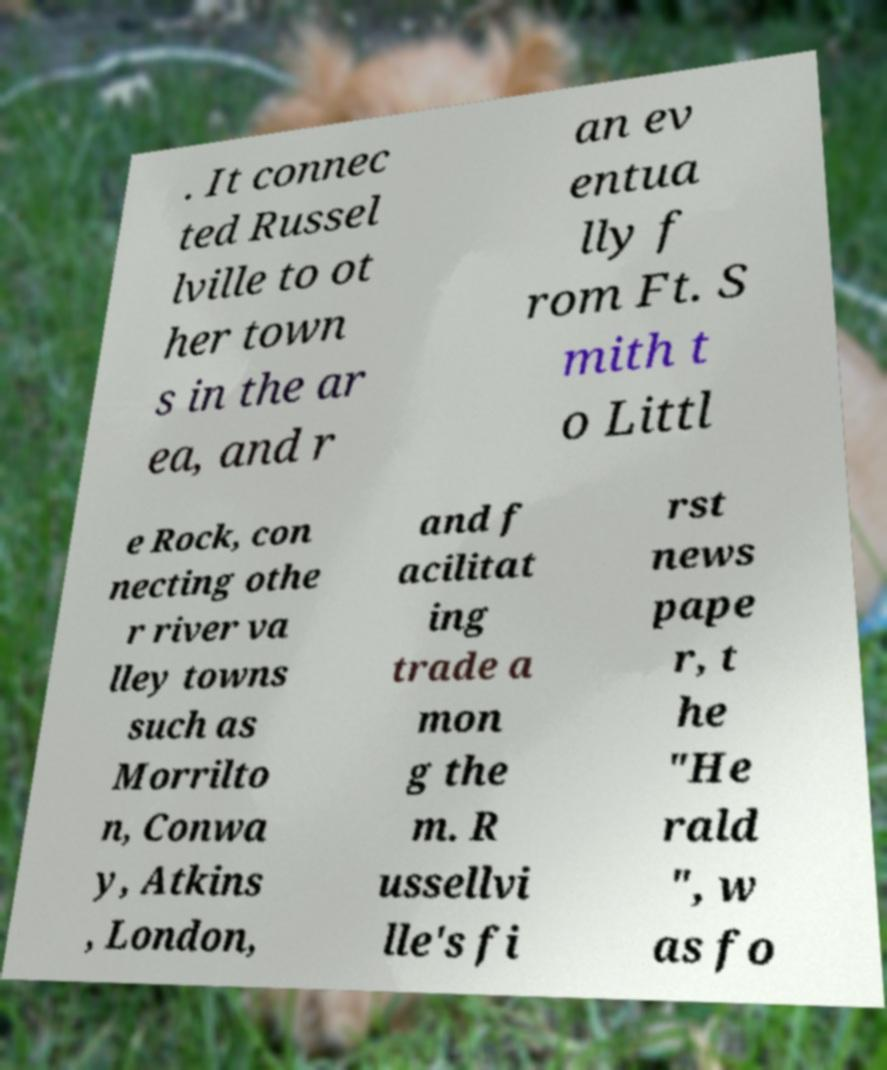For documentation purposes, I need the text within this image transcribed. Could you provide that? . It connec ted Russel lville to ot her town s in the ar ea, and r an ev entua lly f rom Ft. S mith t o Littl e Rock, con necting othe r river va lley towns such as Morrilto n, Conwa y, Atkins , London, and f acilitat ing trade a mon g the m. R ussellvi lle's fi rst news pape r, t he "He rald ", w as fo 